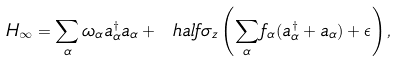<formula> <loc_0><loc_0><loc_500><loc_500>H _ { \infty } = \sum _ { \alpha } \omega _ { \alpha } a _ { \alpha } ^ { \dagger } a _ { \alpha } + \ h a l f { \sigma _ { z } } \left ( \sum _ { \alpha } { f _ { \alpha } ( a _ { \alpha } ^ { \dagger } + a _ { \alpha } ) } + \epsilon \right ) ,</formula> 